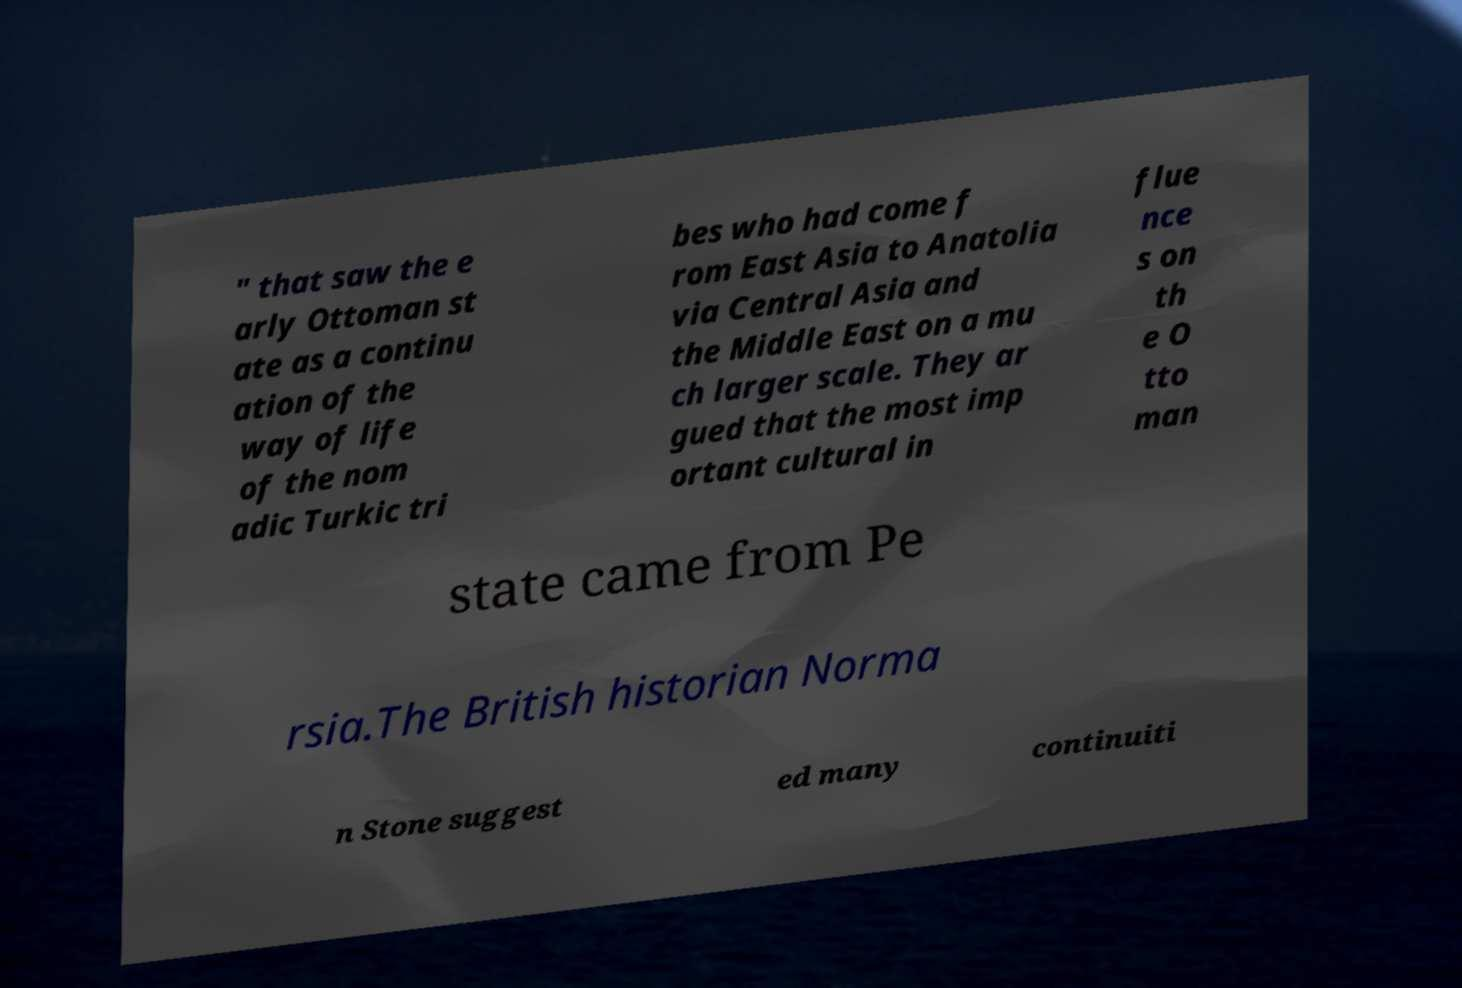What messages or text are displayed in this image? I need them in a readable, typed format. " that saw the e arly Ottoman st ate as a continu ation of the way of life of the nom adic Turkic tri bes who had come f rom East Asia to Anatolia via Central Asia and the Middle East on a mu ch larger scale. They ar gued that the most imp ortant cultural in flue nce s on th e O tto man state came from Pe rsia.The British historian Norma n Stone suggest ed many continuiti 